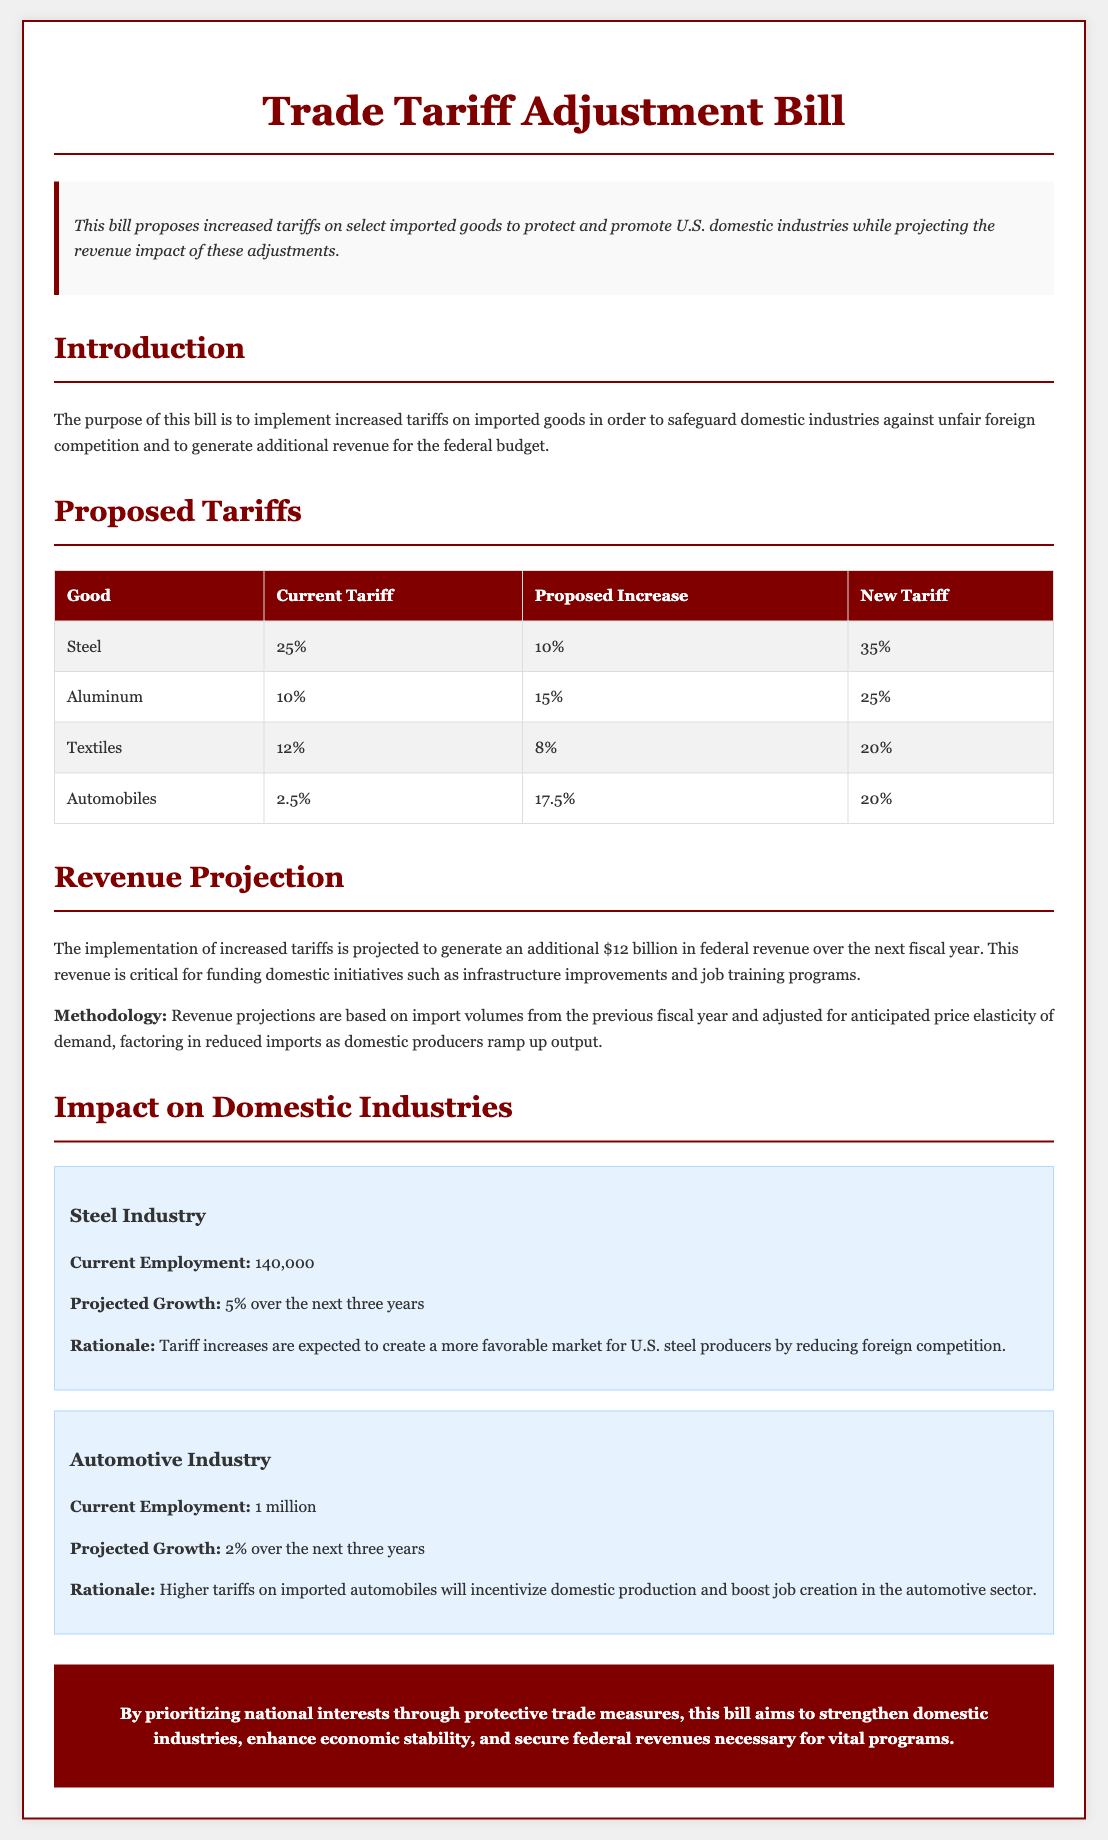What is the proposed increase for steel tariffs? The proposed increase for steel is detailed in the "Proposed Tariffs" section of the document, indicating a 10% increase.
Answer: 10% What is the new tariff rate for aluminum? The new tariff rate for aluminum is found in the "Proposed Tariffs" table, showing a total of 25%.
Answer: 25% What is the projected growth for the steel industry over the next three years? The projected growth for the steel industry is specified in the "Impact on Domestic Industries" section as 5%.
Answer: 5% How much additional federal revenue is projected from the tariff increases? The document states in the "Revenue Projection" section that the additional federal revenue is projected to be $12 billion.
Answer: $12 billion What is the current employment in the automotive industry? The current employment in the automotive industry is provided in the "Impact on Domestic Industries" section, showing 1 million.
Answer: 1 million What rationale is given for increasing tariffs on the automotive industry? The rationale for increasing tariffs is mentioned in the "Impact on Domestic Industries" section, highlighting the incentive for domestic production.
Answer: Incentivize domestic production What is the purpose of the Trade Tariff Adjustment Bill? The purpose is outlined in the "Introduction" section, aimed at implementing increased tariffs to safeguard domestic industries.
Answer: Safeguard domestic industries What is the current tariff on textiles? The current tariff on textiles is listed in the "Proposed Tariffs" table, which shows 12%.
Answer: 12% What will be the new tariff for automobiles? The new tariff for automobiles is indicated in the "Proposed Tariffs" table, which states it will be 20%.
Answer: 20% 